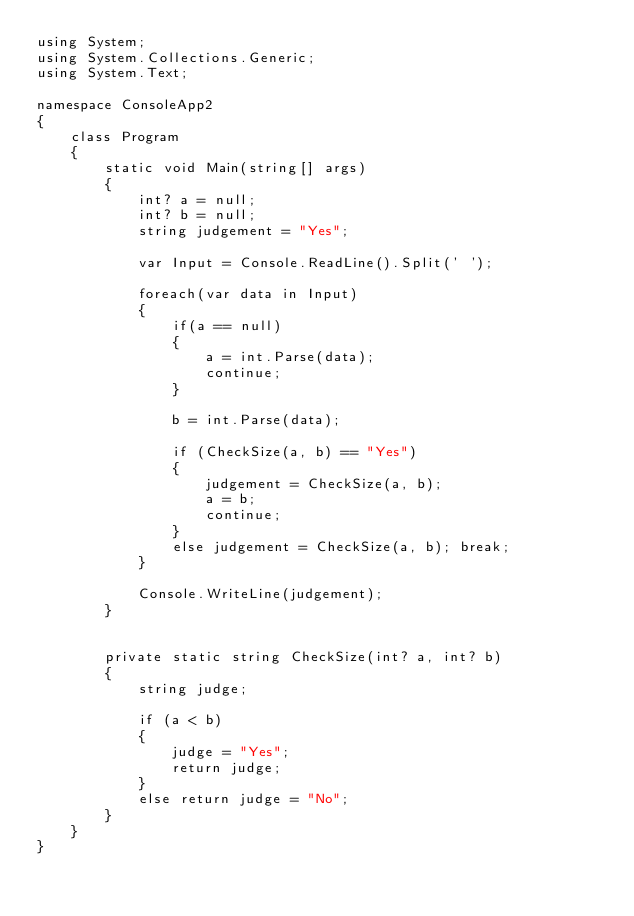Convert code to text. <code><loc_0><loc_0><loc_500><loc_500><_C#_>using System;
using System.Collections.Generic;
using System.Text;

namespace ConsoleApp2
{
    class Program
    {
        static void Main(string[] args)
        {
            int? a = null;
            int? b = null;
            string judgement = "Yes";

            var Input = Console.ReadLine().Split(' ');

            foreach(var data in Input)
            {
                if(a == null)
                {
                    a = int.Parse(data);
                    continue;
                }

                b = int.Parse(data);

                if (CheckSize(a, b) == "Yes")
                {
                    judgement = CheckSize(a, b);
                    a = b;
                    continue;
                }
                else judgement = CheckSize(a, b); break;
            }

            Console.WriteLine(judgement);
        }


        private static string CheckSize(int? a, int? b)
        {
            string judge;

            if (a < b)
            {
                judge = "Yes";
                return judge;
            }
            else return judge = "No";
        }
    }
}</code> 